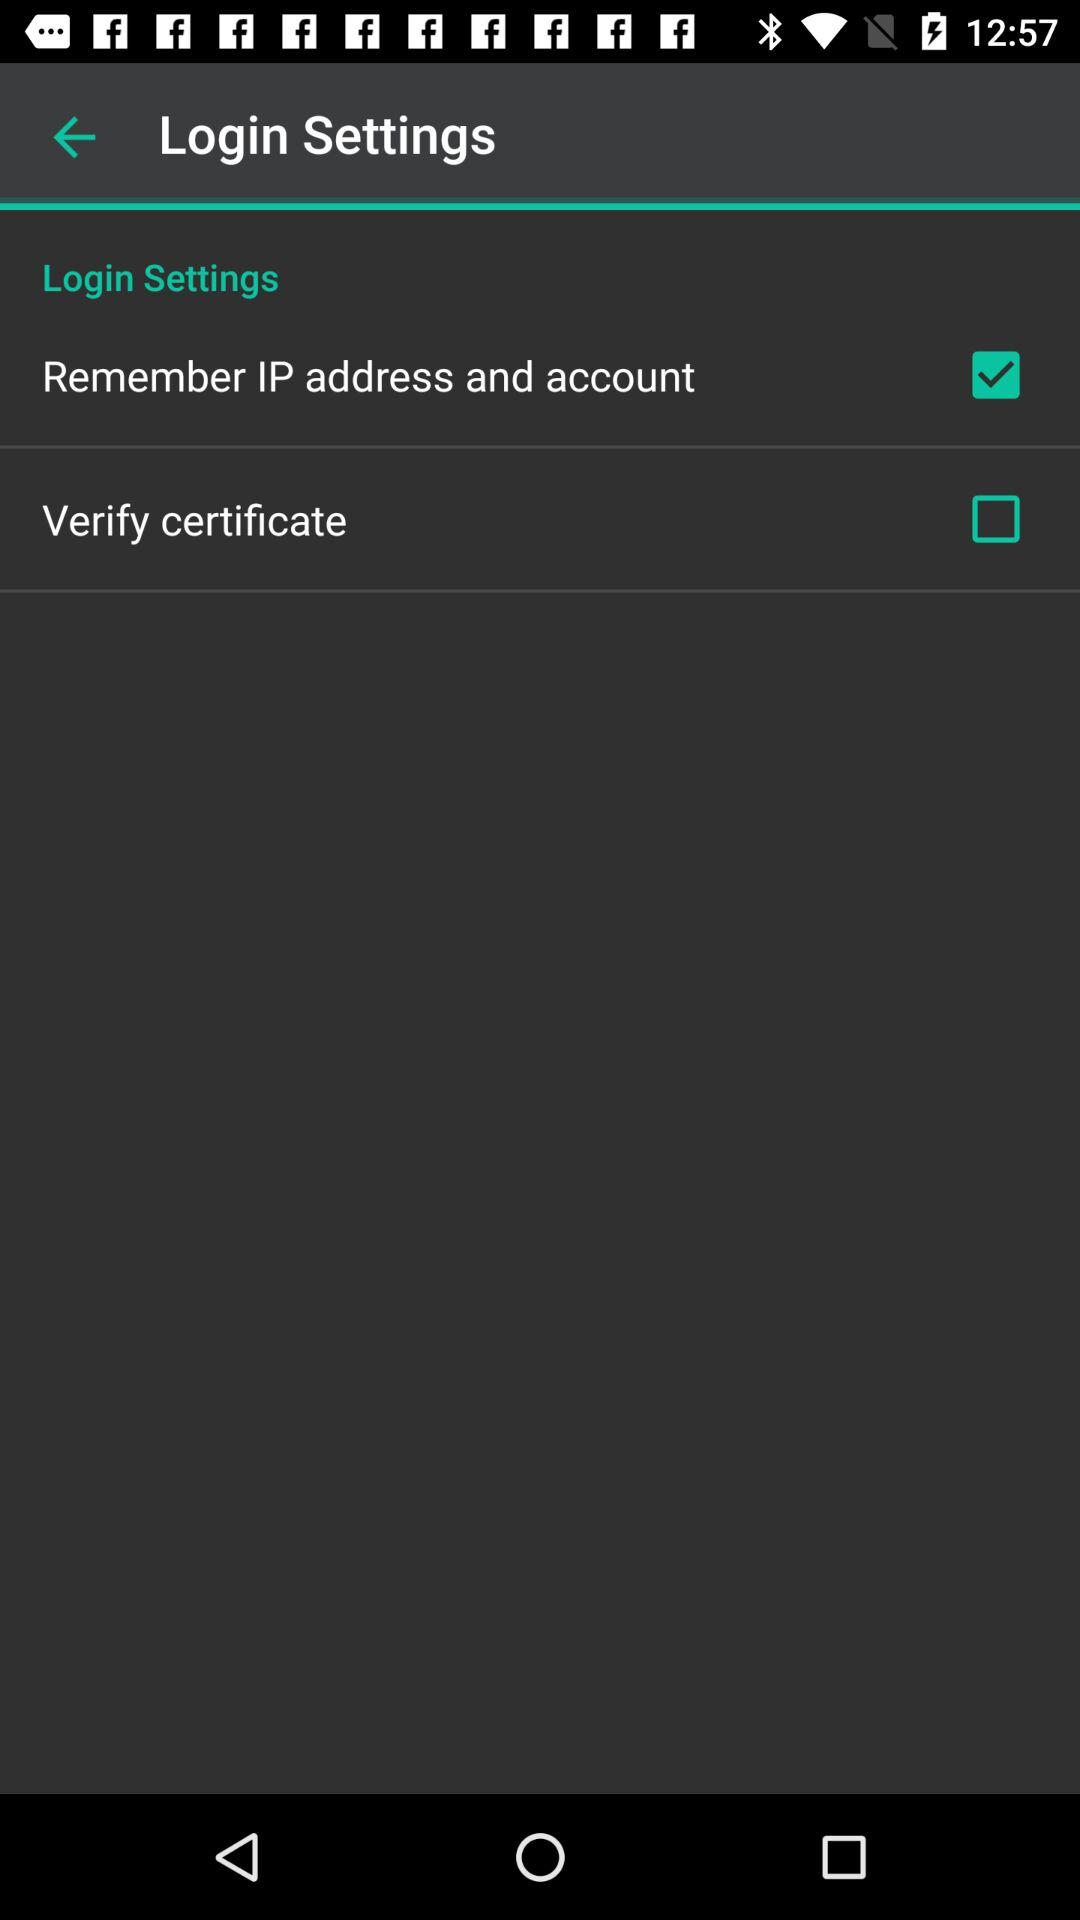What is the status of the "Verify certificate"? The status is off. 